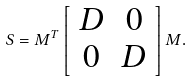<formula> <loc_0><loc_0><loc_500><loc_500>S = M ^ { T } \left [ \begin{array} { c c } D & 0 \\ 0 & D \end{array} \right ] M .</formula> 